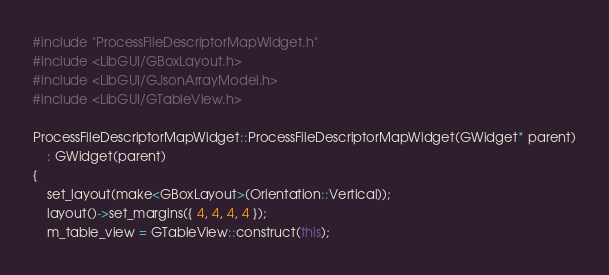Convert code to text. <code><loc_0><loc_0><loc_500><loc_500><_C++_>#include "ProcessFileDescriptorMapWidget.h"
#include <LibGUI/GBoxLayout.h>
#include <LibGUI/GJsonArrayModel.h>
#include <LibGUI/GTableView.h>

ProcessFileDescriptorMapWidget::ProcessFileDescriptorMapWidget(GWidget* parent)
    : GWidget(parent)
{
    set_layout(make<GBoxLayout>(Orientation::Vertical));
    layout()->set_margins({ 4, 4, 4, 4 });
    m_table_view = GTableView::construct(this);</code> 